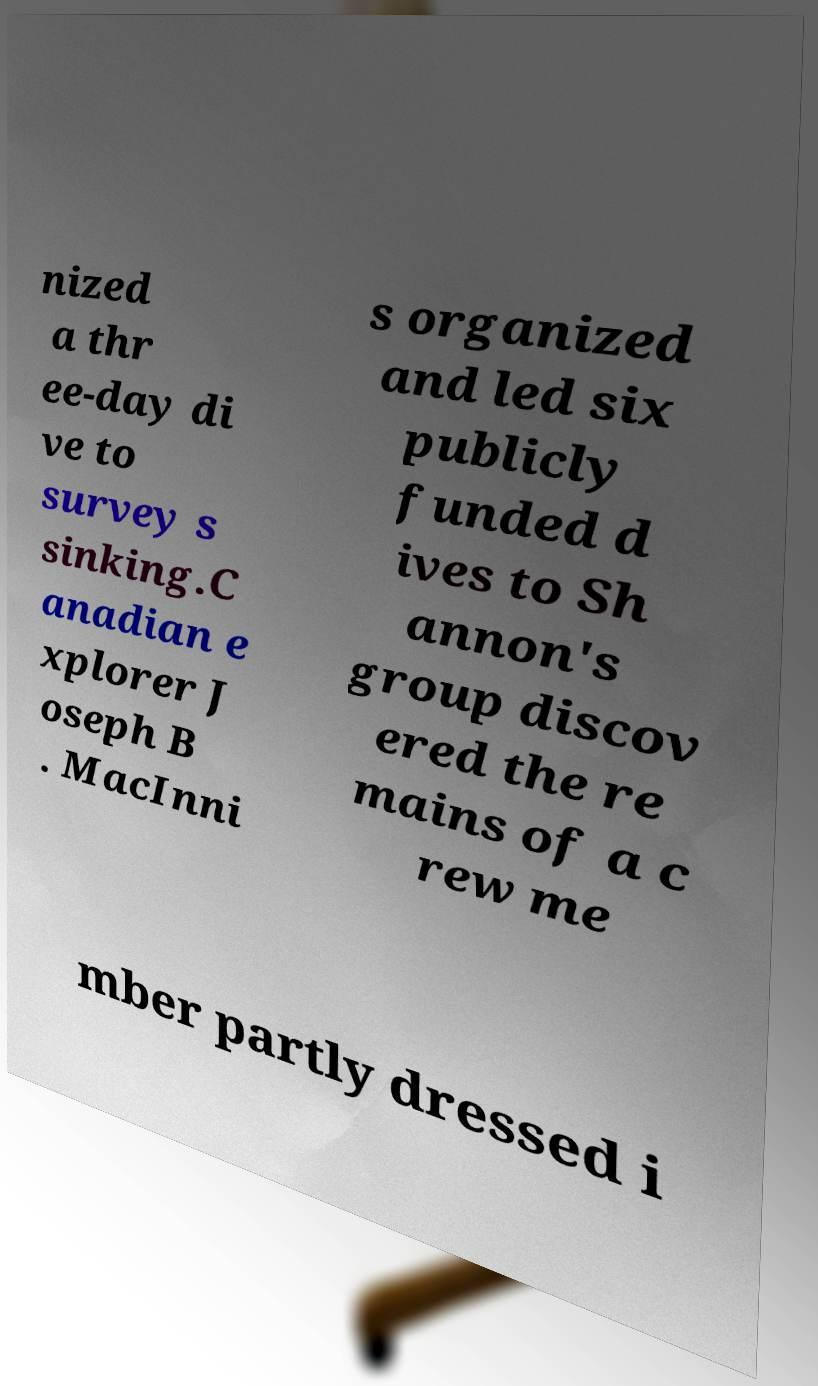I need the written content from this picture converted into text. Can you do that? nized a thr ee-day di ve to survey s sinking.C anadian e xplorer J oseph B . MacInni s organized and led six publicly funded d ives to Sh annon's group discov ered the re mains of a c rew me mber partly dressed i 